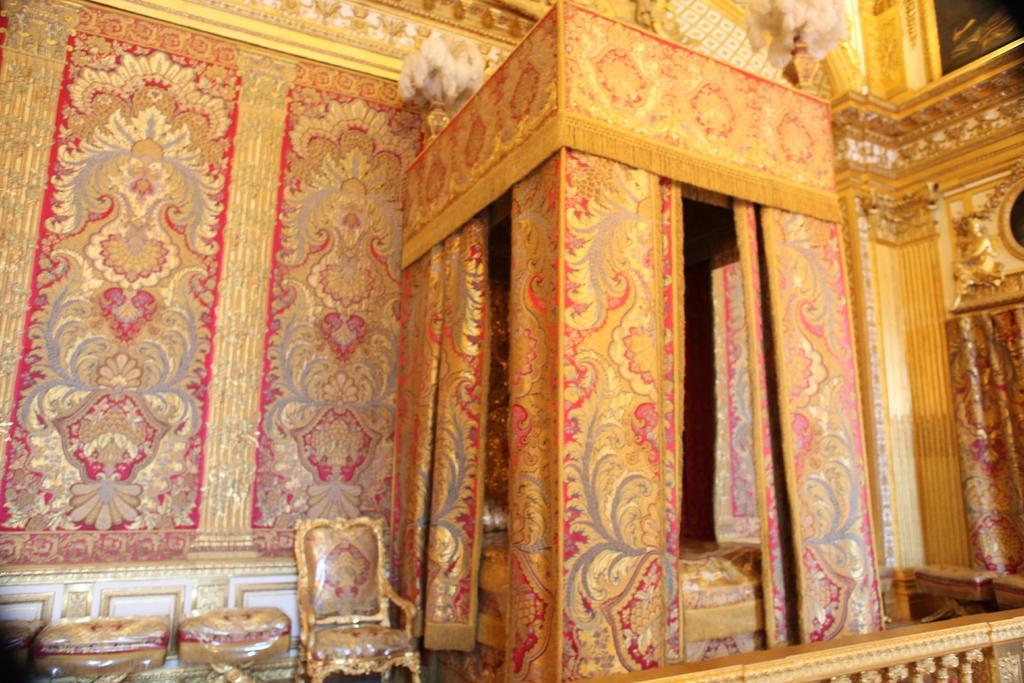Can you describe this image briefly? In this image I can see the inside view of a building. There is a bed, there are curtains, chairs, walls, and some other objects. 